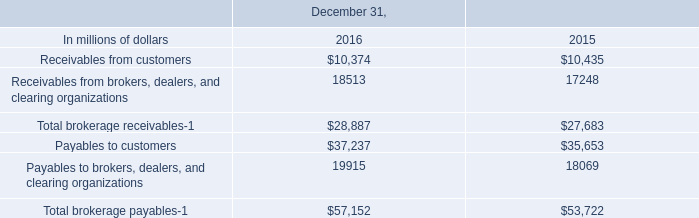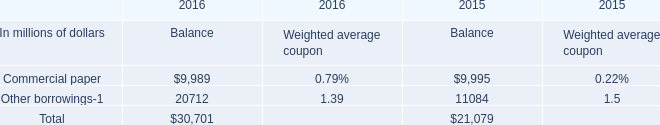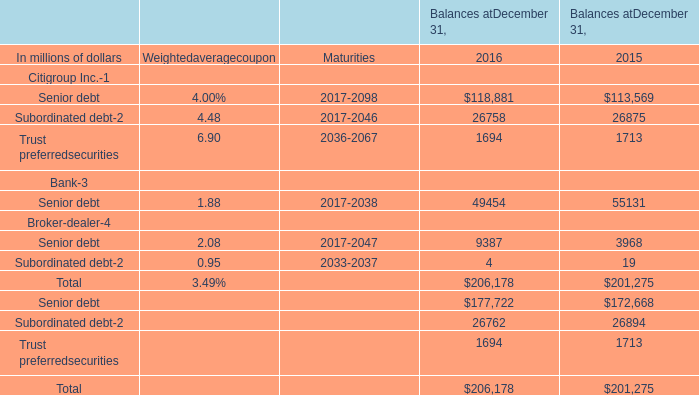What is the sum of elements in the range of 40000 and 120000 in 2016? (in million) 
Computations: (118881 + 49454)
Answer: 168335.0. 